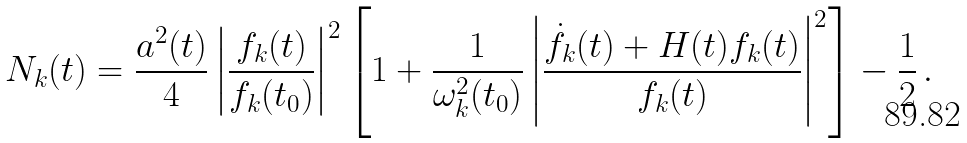<formula> <loc_0><loc_0><loc_500><loc_500>N _ { k } ( t ) = \frac { a ^ { 2 } ( t ) } { 4 } \left | \frac { f _ { k } ( t ) } { f _ { k } ( t _ { 0 } ) } \right | ^ { 2 } \left [ 1 + \frac { 1 } { \omega ^ { 2 } _ { k } ( t _ { 0 } ) } \left | \frac { \dot { f } _ { k } ( t ) + H ( t ) f _ { k } ( t ) } { f _ { k } ( t ) } \right | ^ { 2 } \right ] - \frac { 1 } { 2 } \, .</formula> 